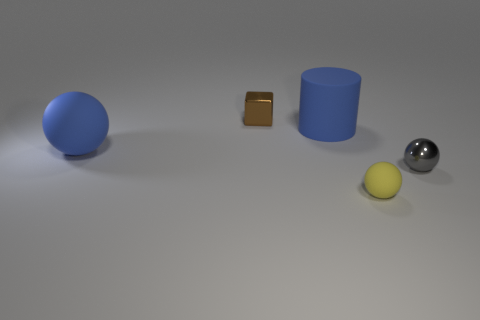Is there anything else that has the same material as the large blue cylinder?
Your answer should be compact. Yes. Do the blue cylinder and the metal ball have the same size?
Offer a terse response. No. Is the small matte thing the same shape as the tiny gray metallic thing?
Give a very brief answer. Yes. There is a big matte object left of the small metallic object that is behind the rubber ball that is left of the small brown thing; what is its shape?
Make the answer very short. Sphere. There is another big matte thing that is the same shape as the gray object; what is its color?
Offer a terse response. Blue. What is the color of the large thing that is to the left of the metal object behind the gray shiny sphere?
Your answer should be very brief. Blue. There is another rubber thing that is the same shape as the yellow object; what size is it?
Your answer should be very brief. Large. What number of brown objects have the same material as the small gray sphere?
Provide a succinct answer. 1. How many blue matte objects are in front of the big blue matte thing that is to the right of the brown block?
Your response must be concise. 1. Are there any small shiny objects behind the gray metallic thing?
Offer a terse response. Yes. 